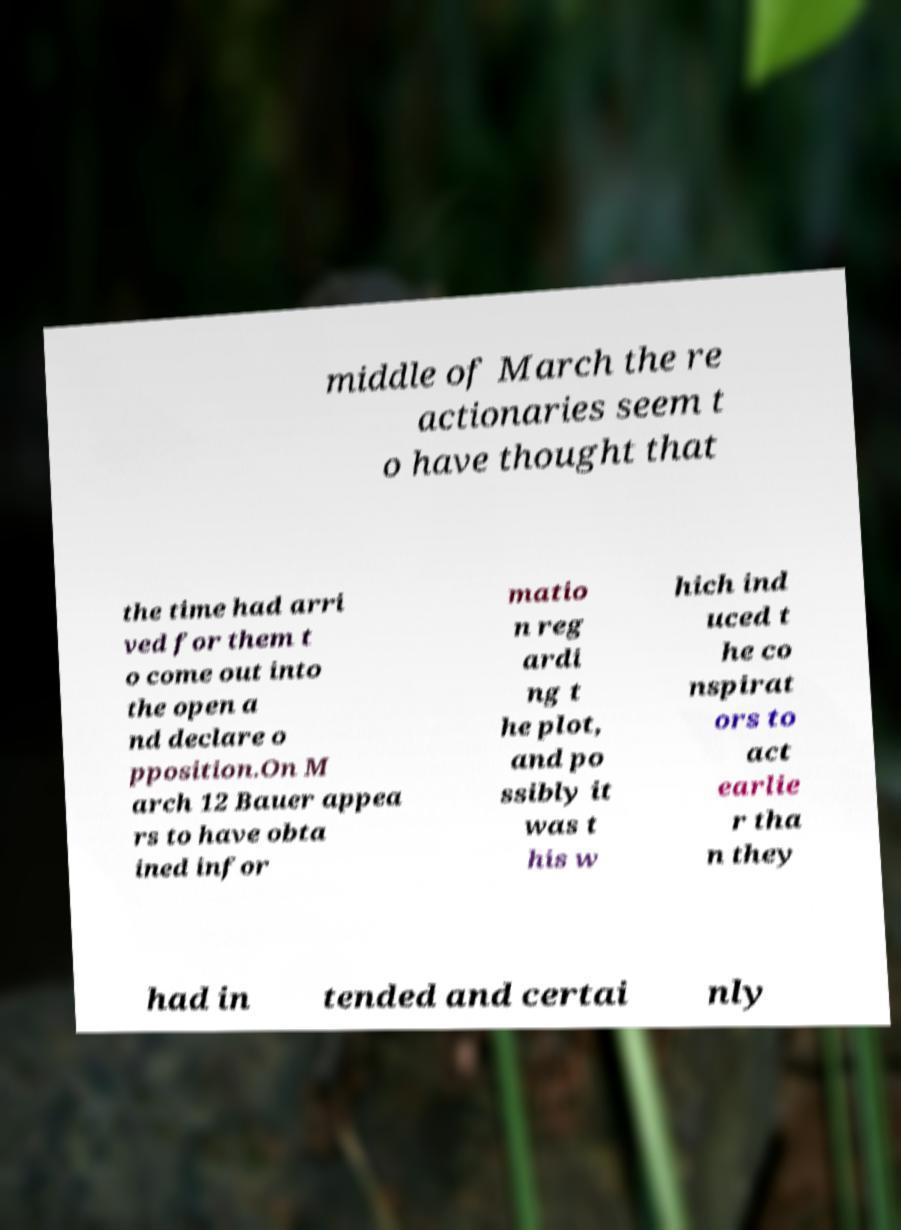Please read and relay the text visible in this image. What does it say? middle of March the re actionaries seem t o have thought that the time had arri ved for them t o come out into the open a nd declare o pposition.On M arch 12 Bauer appea rs to have obta ined infor matio n reg ardi ng t he plot, and po ssibly it was t his w hich ind uced t he co nspirat ors to act earlie r tha n they had in tended and certai nly 